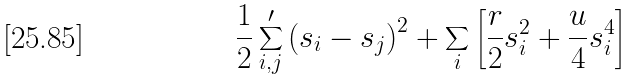<formula> <loc_0><loc_0><loc_500><loc_500>\frac { 1 } { 2 } \sum ^ { \prime } _ { i , j } \left ( s _ { i } - s _ { j } \right ) ^ { 2 } + \sum _ { i } \left [ \frac { r } { 2 } s _ { i } ^ { 2 } + \frac { u } { 4 } s _ { i } ^ { 4 } \right ]</formula> 